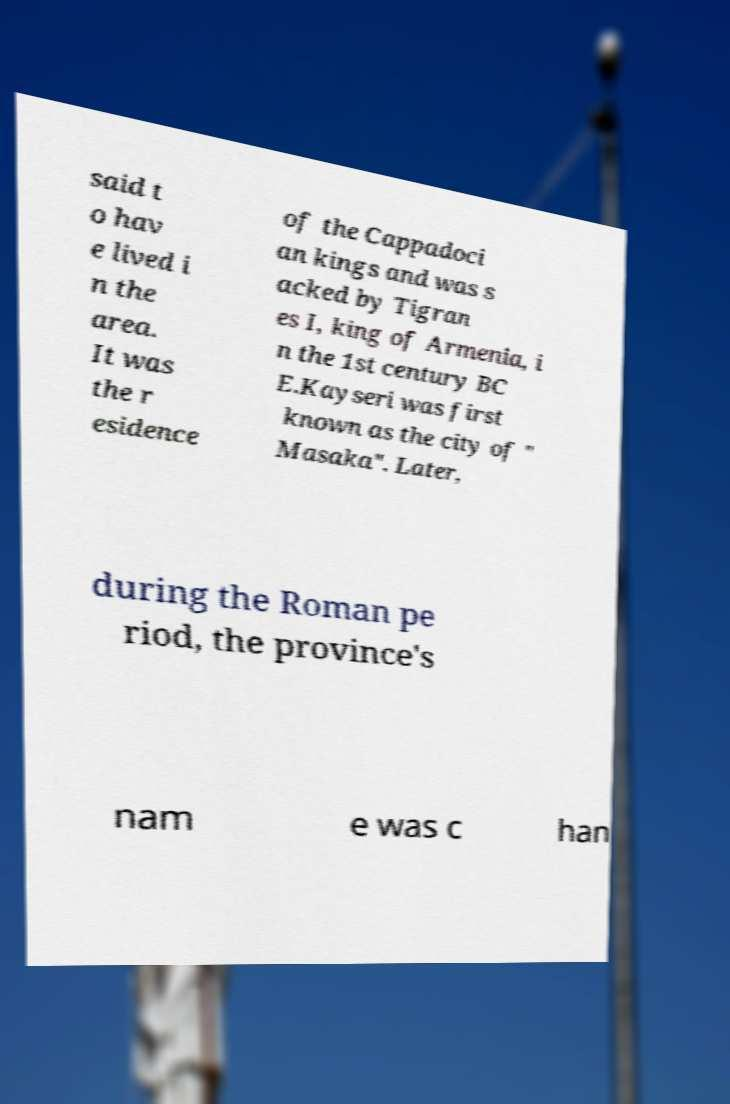I need the written content from this picture converted into text. Can you do that? said t o hav e lived i n the area. It was the r esidence of the Cappadoci an kings and was s acked by Tigran es I, king of Armenia, i n the 1st century BC E.Kayseri was first known as the city of " Masaka". Later, during the Roman pe riod, the province's nam e was c han 